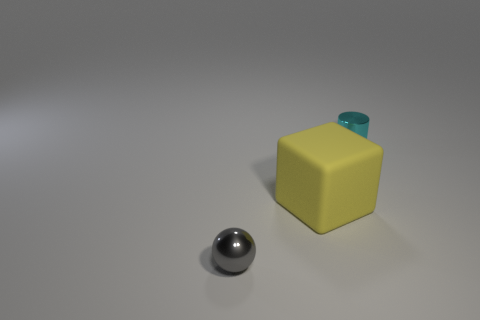Add 1 big gray metal balls. How many objects exist? 4 Subtract all large rubber blocks. Subtract all yellow rubber blocks. How many objects are left? 1 Add 1 cyan shiny things. How many cyan shiny things are left? 2 Add 2 tiny gray objects. How many tiny gray objects exist? 3 Subtract 0 green cylinders. How many objects are left? 3 Subtract all cubes. How many objects are left? 2 